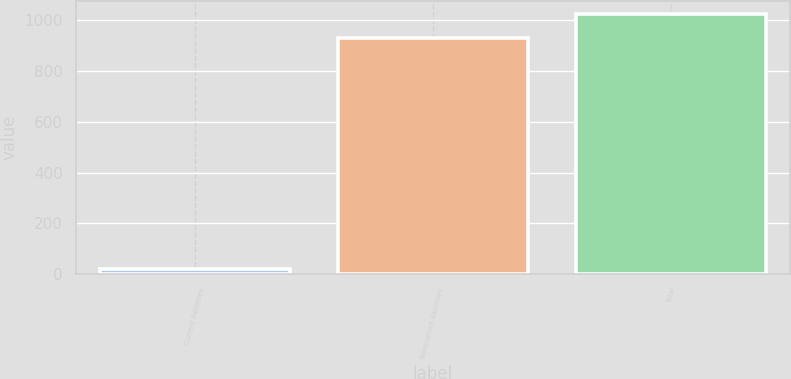Convert chart to OTSL. <chart><loc_0><loc_0><loc_500><loc_500><bar_chart><fcel>Current liabilities<fcel>Noncurrent liabilities<fcel>Total<nl><fcel>21<fcel>931<fcel>1024.1<nl></chart> 